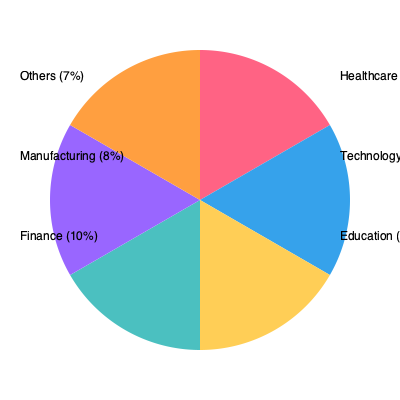Based on the pie chart showing the distribution of professional fields in the community, which sector has the highest representation, and what percentage of professionals does it account for? Additionally, calculate the ratio of professionals in the Technology sector to those in the Education sector. To answer this question, we need to analyze the pie chart and perform some calculations:

1. Identify the largest sector:
   By examining the pie chart, we can see that the largest slice corresponds to Healthcare.

2. Determine the percentage of the Healthcare sector:
   The chart indicates that Healthcare accounts for 30% of professionals in the community.

3. Calculate the ratio of Technology to Education professionals:
   - Technology sector: 25%
   - Education sector: 20%
   
   To find the ratio, we divide the percentage of Technology professionals by the percentage of Education professionals:
   
   $\frac{25\%}{20\%} = \frac{25}{20} = 1.25$

   This can be expressed as a ratio of 5:4 (by dividing both numbers by their greatest common divisor, 5).

Therefore, the sector with the highest representation is Healthcare, accounting for 30% of professionals. The ratio of Technology to Education professionals is 1.25:1 or 5:4.
Answer: Healthcare (30%); 5:4 